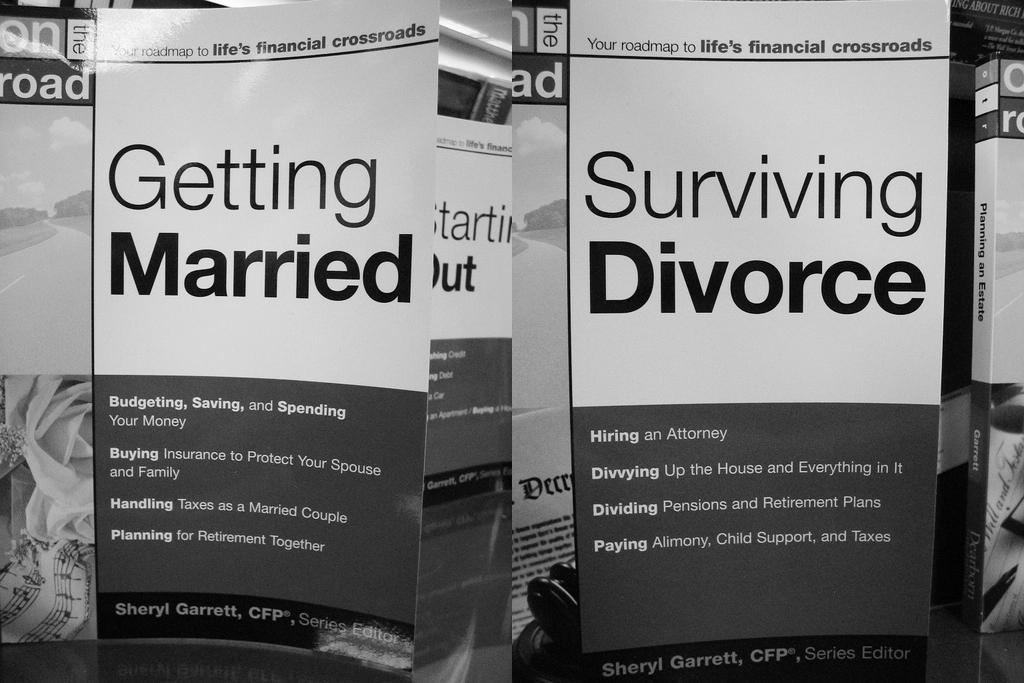<image>
Offer a succinct explanation of the picture presented. The left most paper is called Getting Married 